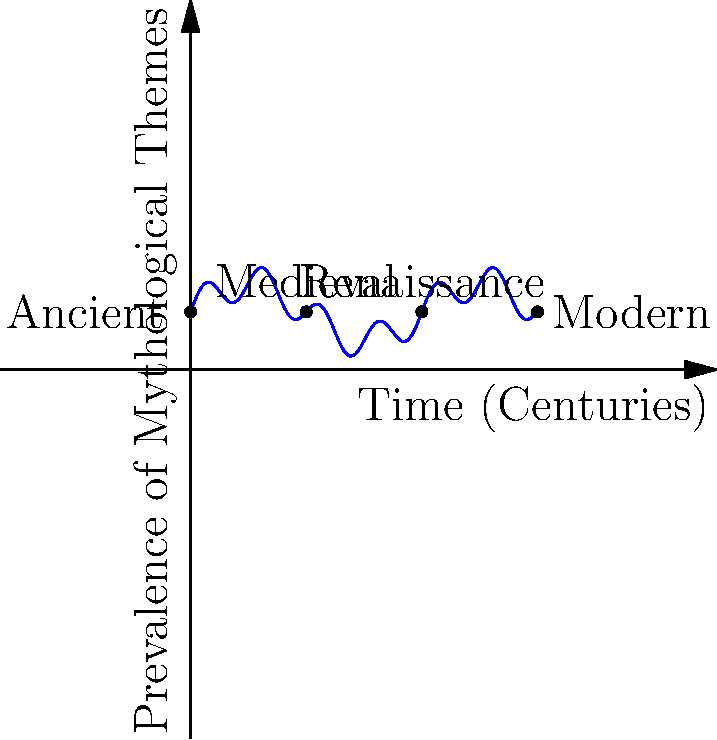In your research on mythological themes across civilizations, you've plotted their prevalence over time using a polynomial function. The graph shows peaks and troughs representing the cyclical nature of these themes. If the current era (Modern) shows a resurgence in mythological themes similar to the Ancient era, what does this suggest about the potential future trajectory of mythological influence in society? To answer this question, let's analyze the graph step-by-step:

1. The graph represents the prevalence of mythological themes over time, from Ancient to Modern eras.

2. The function used is a combination of sine waves, creating a cyclical pattern. This can be represented as:

   $f(x) = 0.5\sin(\frac{\pi x}{2}) + 0.3\sin(2\pi x) + 1$

3. We can observe that:
   - The Ancient era (x = 0) shows a high prevalence of mythological themes.
   - There's a dip during the Medieval period (x ≈ 2).
   - A slight resurgence occurs during the Renaissance (x ≈ 4).
   - The Modern era (x = 6) shows another peak, similar to the Ancient era.

4. The cyclical nature of the graph suggests that mythological themes go through periods of high and low prevalence.

5. Given that the Modern era shows a resurgence similar to the Ancient era, we can extrapolate that:
   - This cycle is likely to continue into the future.
   - We might expect a decline in mythological influence following the current peak, similar to what happened after the Ancient era.
   - However, this decline would likely be followed by another resurgence in the more distant future.

6. This pattern suggests that mythological themes have a persistent, cyclical influence on society, rather than becoming permanently obsolete.

7. For a journalist interviewing authors on this topic, this cyclical pattern could prompt discussions about:
   - Why societies periodically return to mythological themes
   - How modern interpretations of myths differ from ancient ones
   - The role of myths in addressing timeless human concerns
Answer: Cyclical resurgence of mythological influence, with potential future decline followed by another peak 